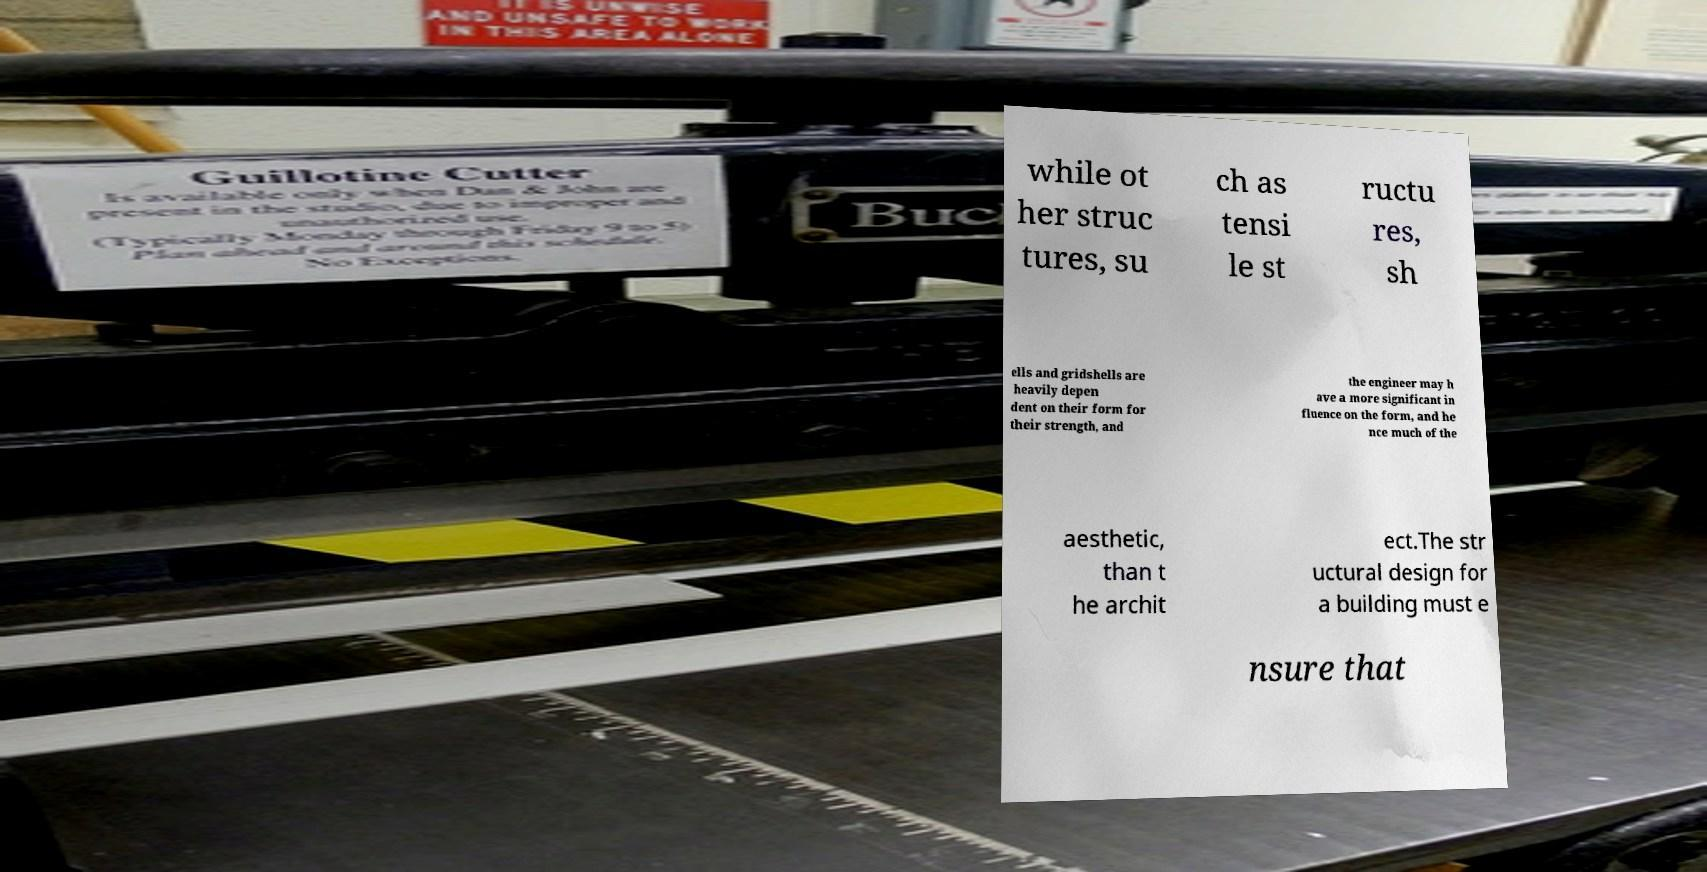Could you extract and type out the text from this image? while ot her struc tures, su ch as tensi le st ructu res, sh ells and gridshells are heavily depen dent on their form for their strength, and the engineer may h ave a more significant in fluence on the form, and he nce much of the aesthetic, than t he archit ect.The str uctural design for a building must e nsure that 